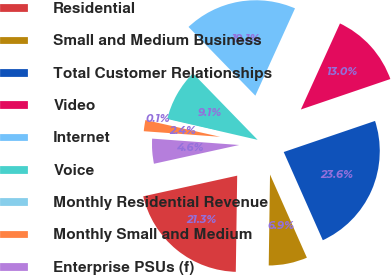Convert chart. <chart><loc_0><loc_0><loc_500><loc_500><pie_chart><fcel>Residential<fcel>Small and Medium Business<fcel>Total Customer Relationships<fcel>Video<fcel>Internet<fcel>Voice<fcel>Monthly Residential Revenue<fcel>Monthly Small and Medium<fcel>Enterprise PSUs (f)<nl><fcel>21.32%<fcel>6.87%<fcel>23.58%<fcel>12.99%<fcel>19.06%<fcel>9.12%<fcel>0.09%<fcel>2.35%<fcel>4.61%<nl></chart> 